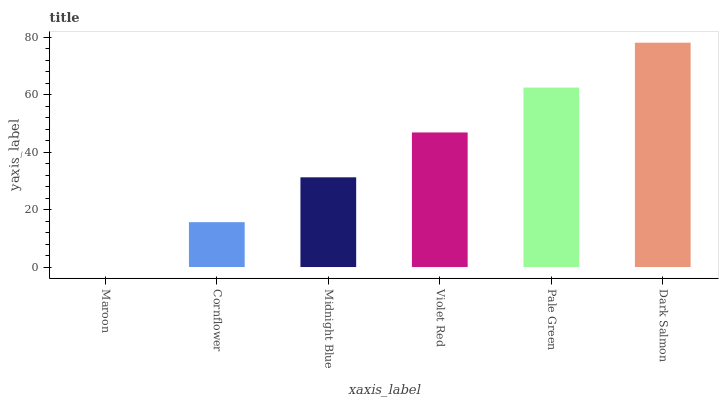Is Maroon the minimum?
Answer yes or no. Yes. Is Dark Salmon the maximum?
Answer yes or no. Yes. Is Cornflower the minimum?
Answer yes or no. No. Is Cornflower the maximum?
Answer yes or no. No. Is Cornflower greater than Maroon?
Answer yes or no. Yes. Is Maroon less than Cornflower?
Answer yes or no. Yes. Is Maroon greater than Cornflower?
Answer yes or no. No. Is Cornflower less than Maroon?
Answer yes or no. No. Is Violet Red the high median?
Answer yes or no. Yes. Is Midnight Blue the low median?
Answer yes or no. Yes. Is Dark Salmon the high median?
Answer yes or no. No. Is Dark Salmon the low median?
Answer yes or no. No. 